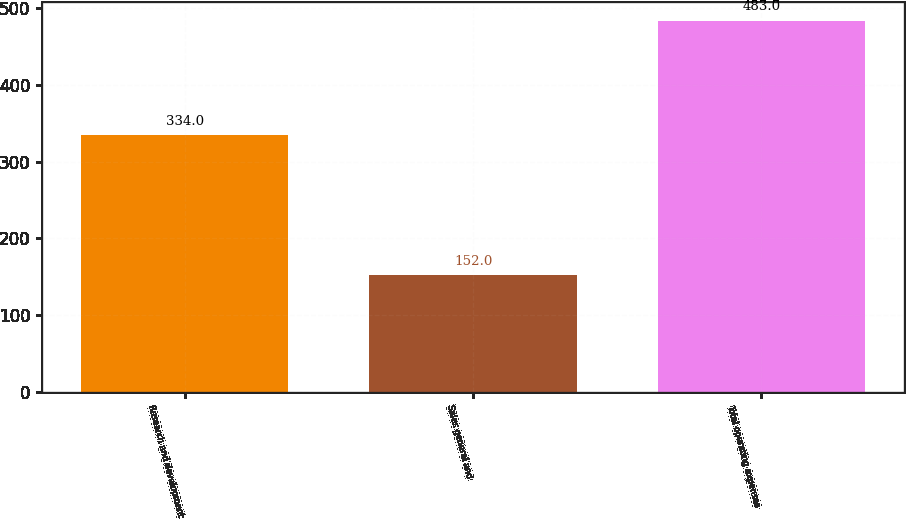Convert chart to OTSL. <chart><loc_0><loc_0><loc_500><loc_500><bar_chart><fcel>Research and development<fcel>Sales general and<fcel>Total operating expenses<nl><fcel>334<fcel>152<fcel>483<nl></chart> 